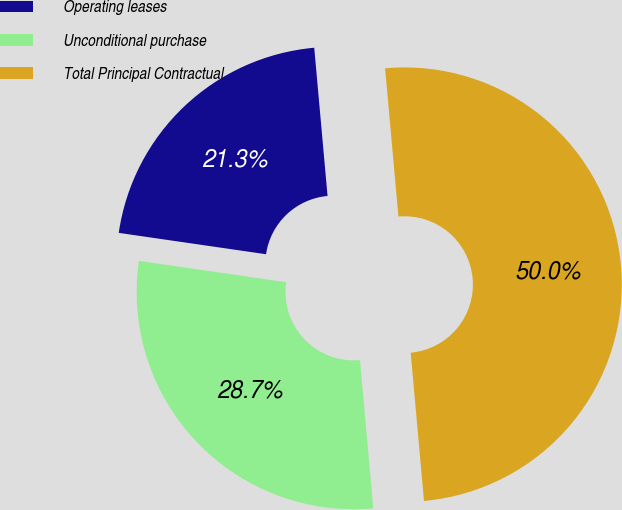<chart> <loc_0><loc_0><loc_500><loc_500><pie_chart><fcel>Operating leases<fcel>Unconditional purchase<fcel>Total Principal Contractual<nl><fcel>21.28%<fcel>28.72%<fcel>50.0%<nl></chart> 